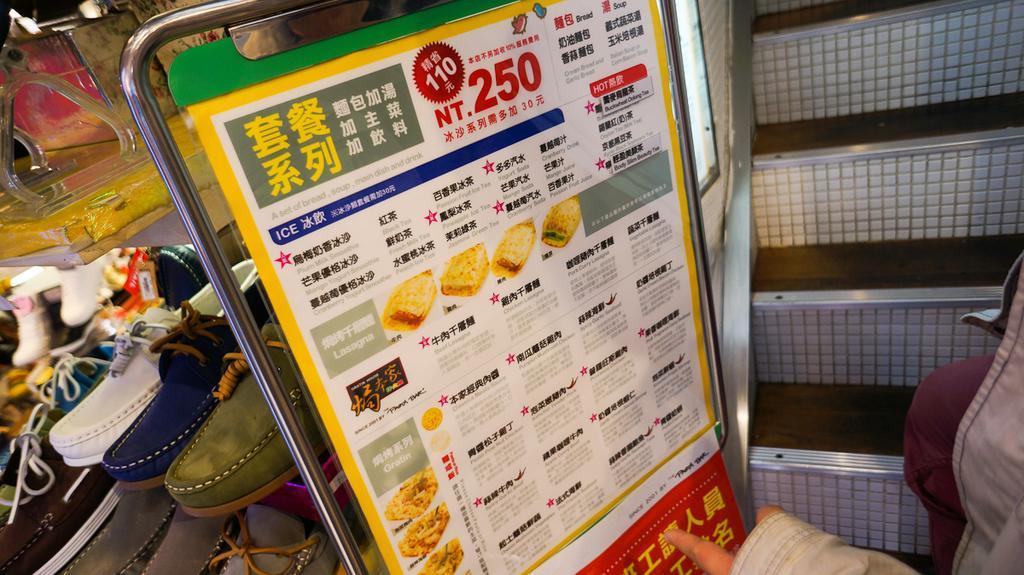Could you give a brief overview of what you see in this image? In this image we can see different kinds of shoes arranged in the shelves, person standing, staircase and an information board. 